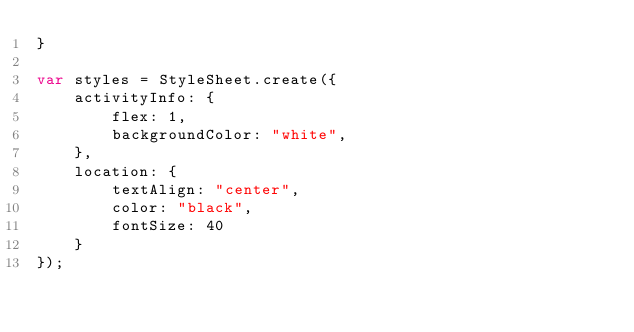<code> <loc_0><loc_0><loc_500><loc_500><_JavaScript_>}

var styles = StyleSheet.create({
    activityInfo: {
        flex: 1,
        backgroundColor: "white",
    },
    location: {
        textAlign: "center",
        color: "black",
        fontSize: 40
    }
});</code> 